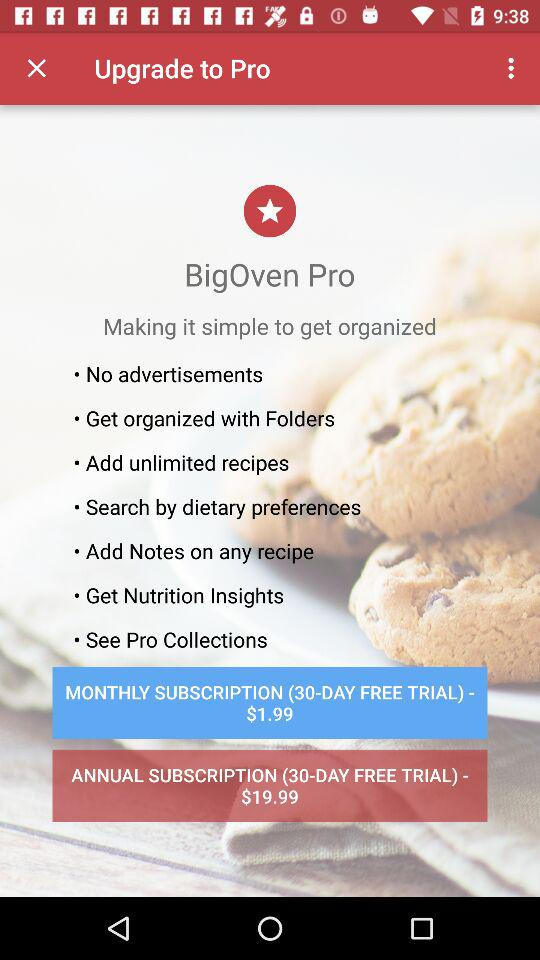What is the annual subscription price? The annual subscription price is $19.99. 